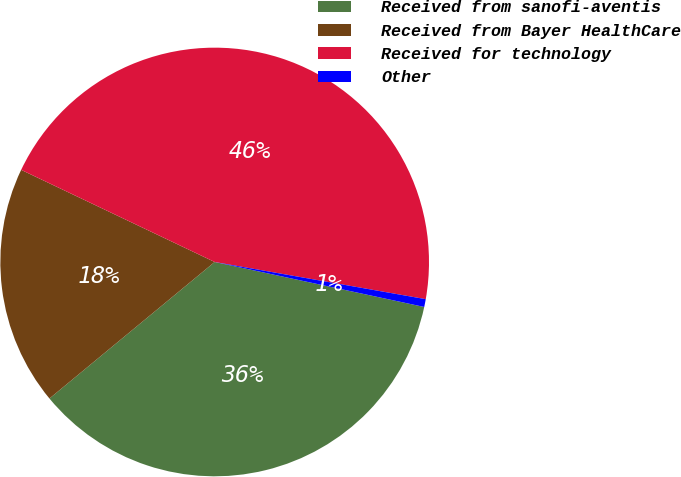Convert chart. <chart><loc_0><loc_0><loc_500><loc_500><pie_chart><fcel>Received from sanofi-aventis<fcel>Received from Bayer HealthCare<fcel>Received for technology<fcel>Other<nl><fcel>35.64%<fcel>18.06%<fcel>45.7%<fcel>0.59%<nl></chart> 